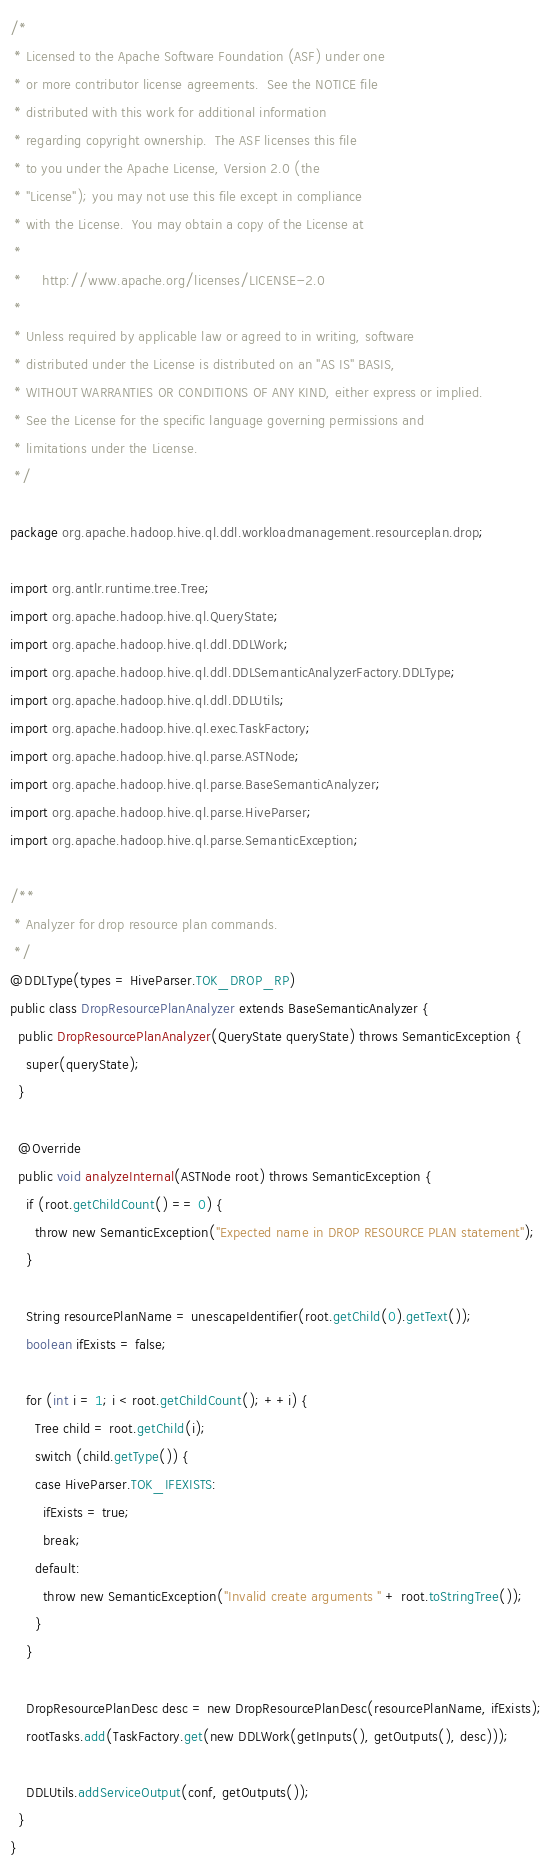<code> <loc_0><loc_0><loc_500><loc_500><_Java_>/*
 * Licensed to the Apache Software Foundation (ASF) under one
 * or more contributor license agreements.  See the NOTICE file
 * distributed with this work for additional information
 * regarding copyright ownership.  The ASF licenses this file
 * to you under the Apache License, Version 2.0 (the
 * "License"); you may not use this file except in compliance
 * with the License.  You may obtain a copy of the License at
 *
 *     http://www.apache.org/licenses/LICENSE-2.0
 *
 * Unless required by applicable law or agreed to in writing, software
 * distributed under the License is distributed on an "AS IS" BASIS,
 * WITHOUT WARRANTIES OR CONDITIONS OF ANY KIND, either express or implied.
 * See the License for the specific language governing permissions and
 * limitations under the License.
 */

package org.apache.hadoop.hive.ql.ddl.workloadmanagement.resourceplan.drop;

import org.antlr.runtime.tree.Tree;
import org.apache.hadoop.hive.ql.QueryState;
import org.apache.hadoop.hive.ql.ddl.DDLWork;
import org.apache.hadoop.hive.ql.ddl.DDLSemanticAnalyzerFactory.DDLType;
import org.apache.hadoop.hive.ql.ddl.DDLUtils;
import org.apache.hadoop.hive.ql.exec.TaskFactory;
import org.apache.hadoop.hive.ql.parse.ASTNode;
import org.apache.hadoop.hive.ql.parse.BaseSemanticAnalyzer;
import org.apache.hadoop.hive.ql.parse.HiveParser;
import org.apache.hadoop.hive.ql.parse.SemanticException;

/**
 * Analyzer for drop resource plan commands.
 */
@DDLType(types = HiveParser.TOK_DROP_RP)
public class DropResourcePlanAnalyzer extends BaseSemanticAnalyzer {
  public DropResourcePlanAnalyzer(QueryState queryState) throws SemanticException {
    super(queryState);
  }

  @Override
  public void analyzeInternal(ASTNode root) throws SemanticException {
    if (root.getChildCount() == 0) {
      throw new SemanticException("Expected name in DROP RESOURCE PLAN statement");
    }

    String resourcePlanName = unescapeIdentifier(root.getChild(0).getText());
    boolean ifExists = false;

    for (int i = 1; i < root.getChildCount(); ++i) {
      Tree child = root.getChild(i);
      switch (child.getType()) {
      case HiveParser.TOK_IFEXISTS:
        ifExists = true;
        break;
      default:
        throw new SemanticException("Invalid create arguments " + root.toStringTree());
      }
    }

    DropResourcePlanDesc desc = new DropResourcePlanDesc(resourcePlanName, ifExists);
    rootTasks.add(TaskFactory.get(new DDLWork(getInputs(), getOutputs(), desc)));

    DDLUtils.addServiceOutput(conf, getOutputs());
  }
}
</code> 